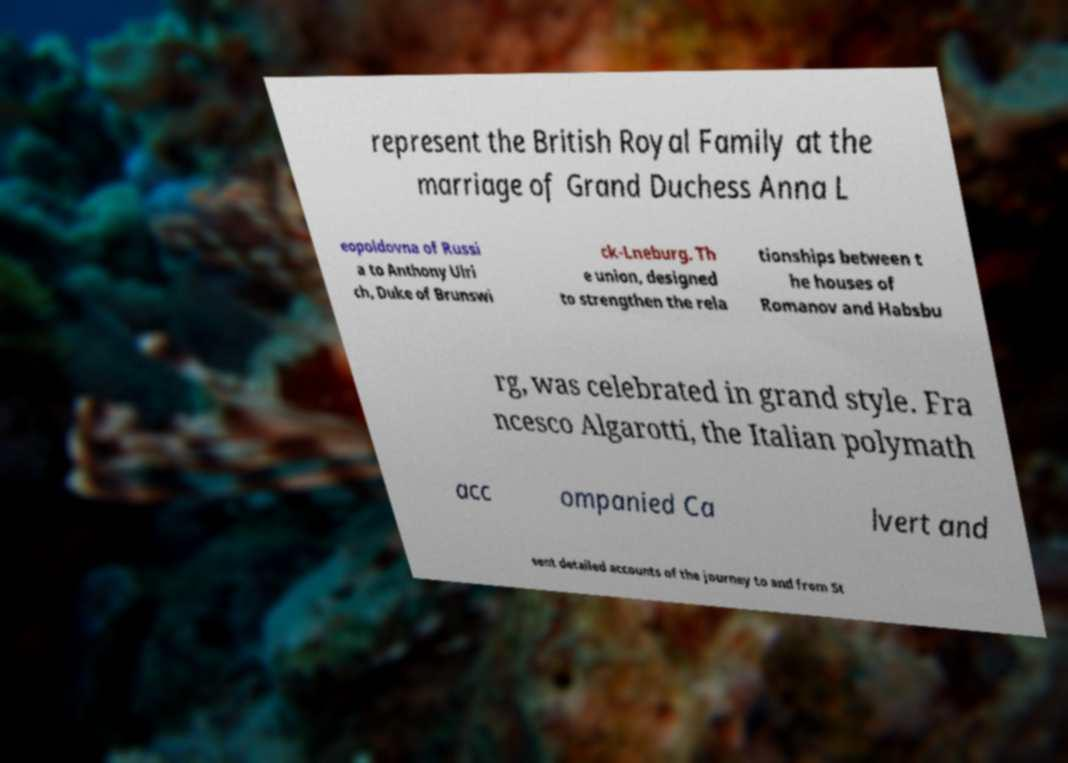There's text embedded in this image that I need extracted. Can you transcribe it verbatim? represent the British Royal Family at the marriage of Grand Duchess Anna L eopoldovna of Russi a to Anthony Ulri ch, Duke of Brunswi ck-Lneburg. Th e union, designed to strengthen the rela tionships between t he houses of Romanov and Habsbu rg, was celebrated in grand style. Fra ncesco Algarotti, the Italian polymath acc ompanied Ca lvert and sent detailed accounts of the journey to and from St 